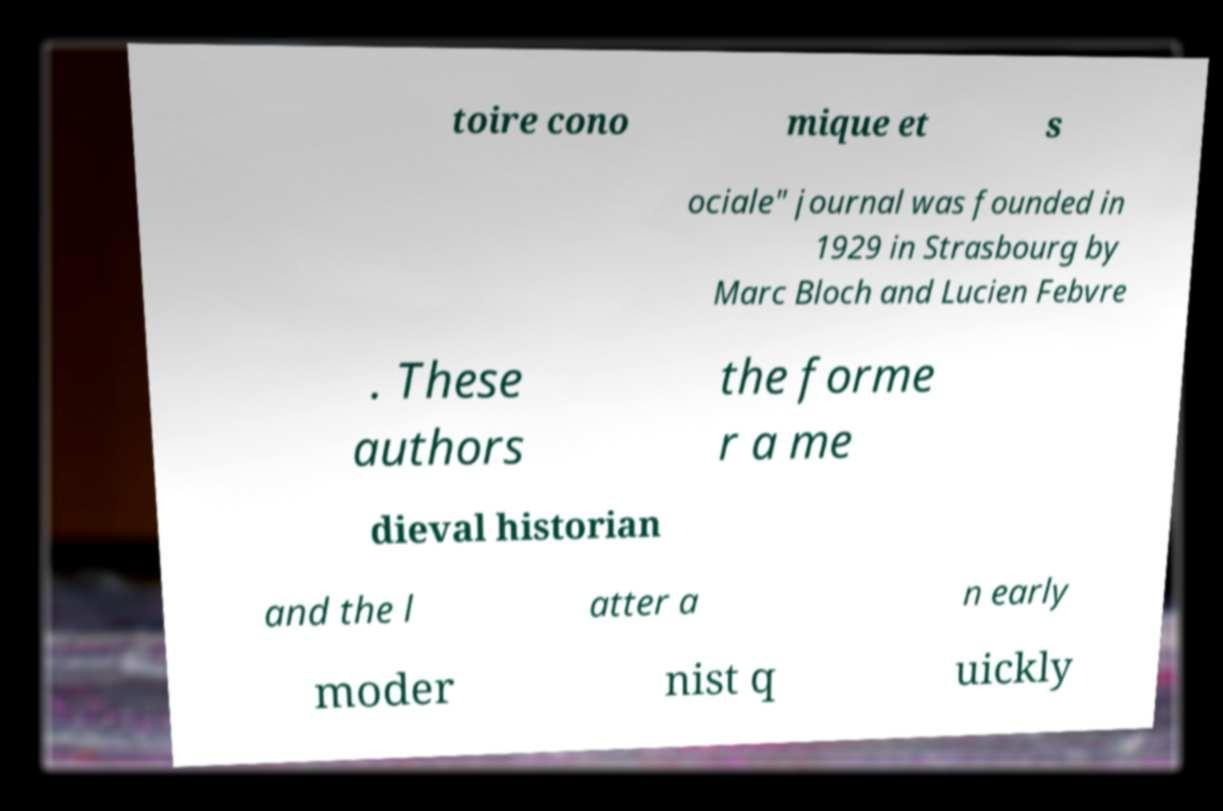Can you read and provide the text displayed in the image?This photo seems to have some interesting text. Can you extract and type it out for me? toire cono mique et s ociale" journal was founded in 1929 in Strasbourg by Marc Bloch and Lucien Febvre . These authors the forme r a me dieval historian and the l atter a n early moder nist q uickly 